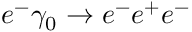Convert formula to latex. <formula><loc_0><loc_0><loc_500><loc_500>e ^ { - } \gamma _ { 0 } \rightarrow e ^ { - } e ^ { + } e ^ { - }</formula> 